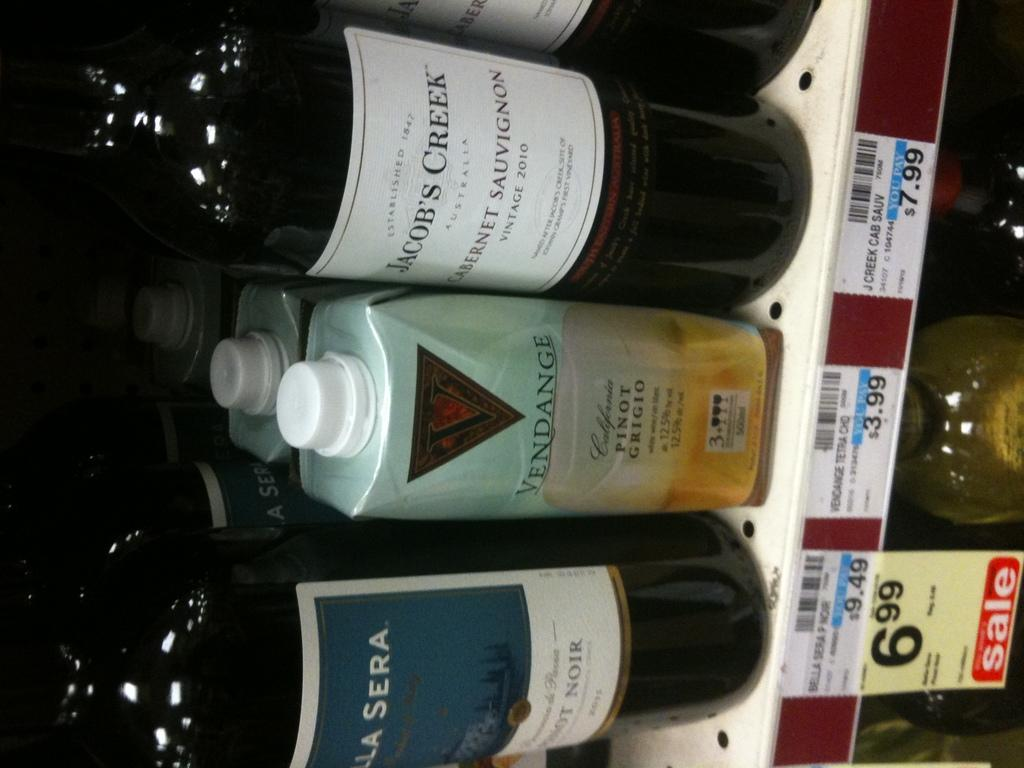<image>
Render a clear and concise summary of the photo. Bottles of wine sitting next to each other with one of them being on Sale. 